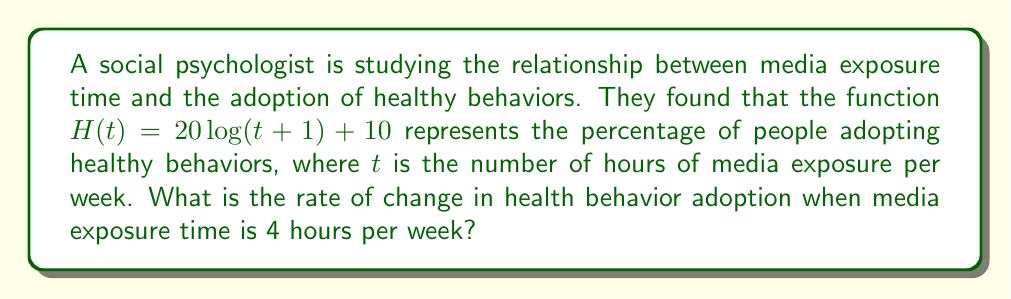Can you solve this math problem? To find the rate of change in health behavior adoption, we need to calculate the derivative of the given function $H(t)$ and then evaluate it at $t=4$.

Step 1: Calculate the derivative of $H(t)$
$$H(t) = 20\log(t+1) + 10$$
$$H'(t) = 20 \cdot \frac{d}{dt}[\log(t+1)]$$
$$H'(t) = 20 \cdot \frac{1}{t+1}$$

Step 2: Evaluate $H'(t)$ at $t=4$
$$H'(4) = 20 \cdot \frac{1}{4+1}$$
$$H'(4) = 20 \cdot \frac{1}{5}$$
$$H'(4) = 4$$

Therefore, when media exposure time is 4 hours per week, the rate of change in health behavior adoption is 4 percentage points per hour of additional media exposure.
Answer: 4 percentage points per hour 